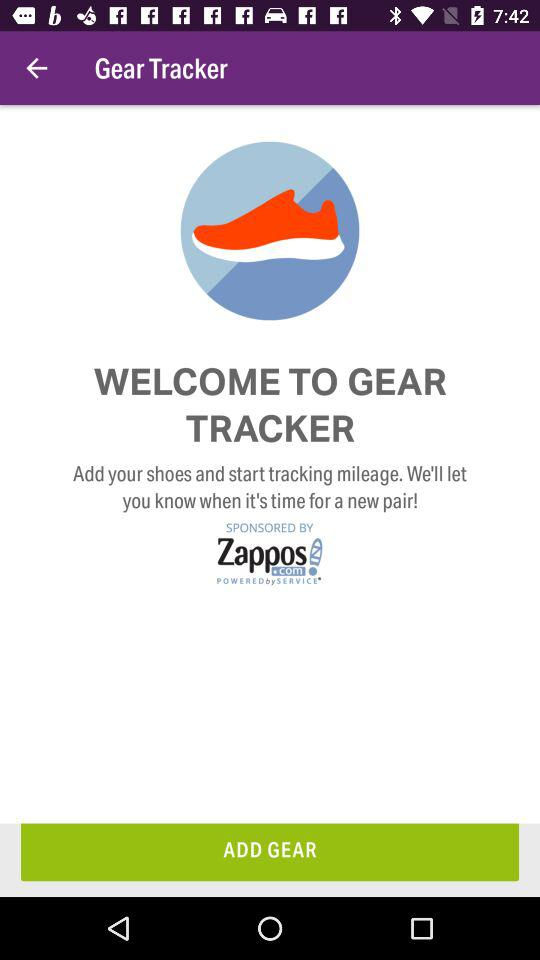What is the application name? The application name is "Gear Tracker". 